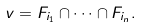<formula> <loc_0><loc_0><loc_500><loc_500>v = F _ { i _ { 1 } } \cap \cdots \cap F _ { i _ { n } } .</formula> 